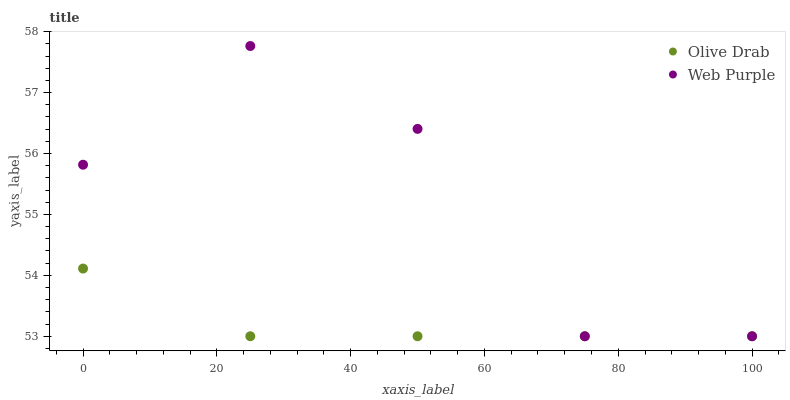Does Olive Drab have the minimum area under the curve?
Answer yes or no. Yes. Does Web Purple have the maximum area under the curve?
Answer yes or no. Yes. Does Olive Drab have the maximum area under the curve?
Answer yes or no. No. Is Olive Drab the smoothest?
Answer yes or no. Yes. Is Web Purple the roughest?
Answer yes or no. Yes. Is Olive Drab the roughest?
Answer yes or no. No. Does Web Purple have the lowest value?
Answer yes or no. Yes. Does Web Purple have the highest value?
Answer yes or no. Yes. Does Olive Drab have the highest value?
Answer yes or no. No. Does Web Purple intersect Olive Drab?
Answer yes or no. Yes. Is Web Purple less than Olive Drab?
Answer yes or no. No. Is Web Purple greater than Olive Drab?
Answer yes or no. No. 